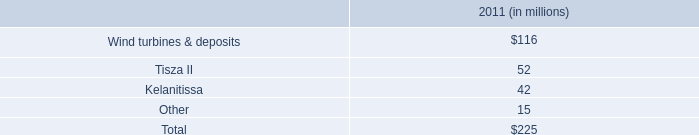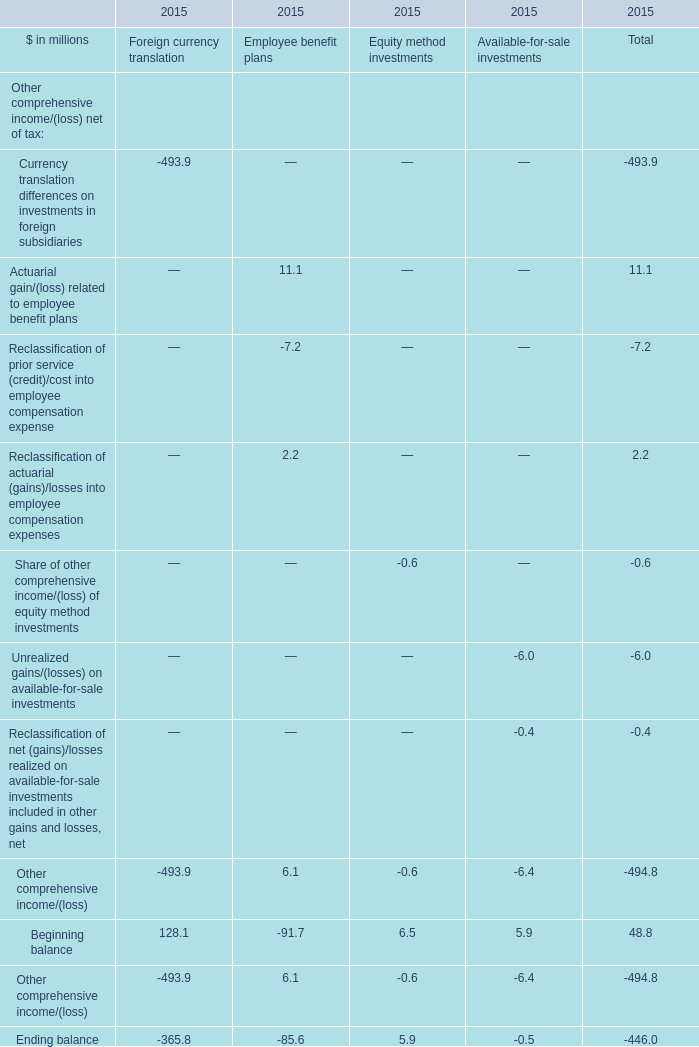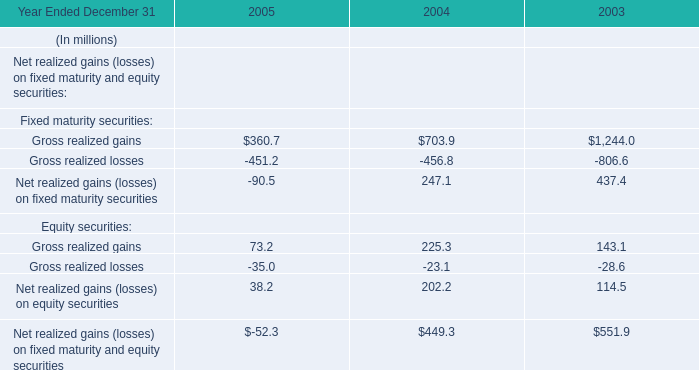during 2011 , what percentage of the wind turbines & deposits were written down? 
Computations: (116 / 161)
Answer: 0.7205. 